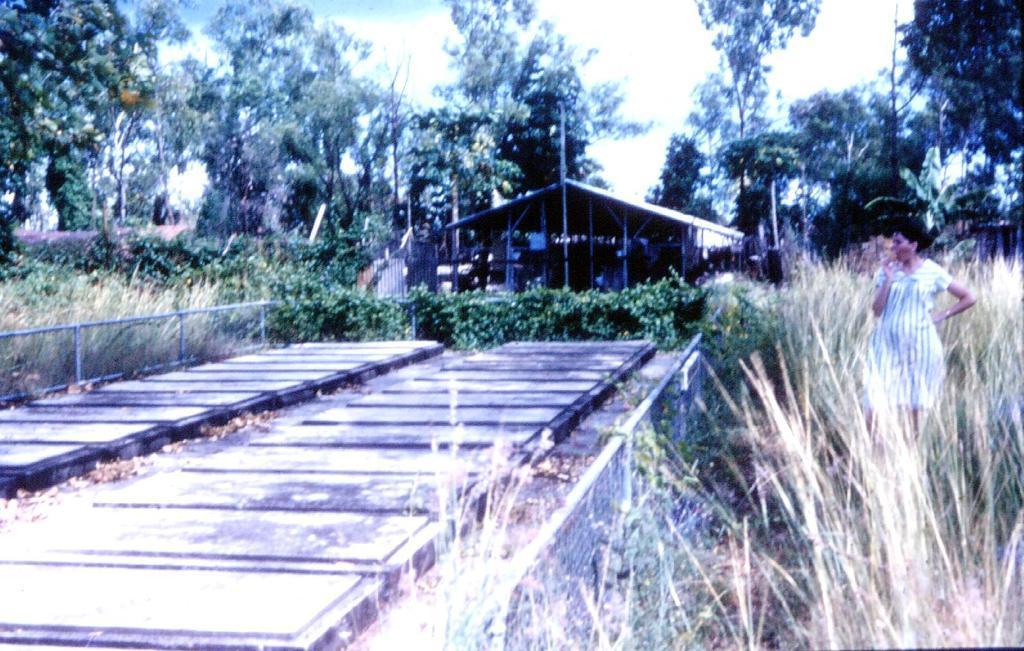Can you describe this image briefly? This is an outside view. On the right side there is a woman standing facing towards the left side. On the ground I can see the grass. In the background there are many plants, trees and also I can see a shed. At the top of the image I can see the sky. 